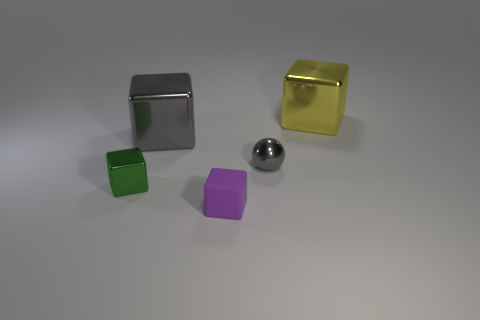There is a small green object; what number of objects are in front of it?
Provide a succinct answer. 1. What color is the other small thing that is the same shape as the green thing?
Offer a terse response. Purple. Does the large cube that is to the left of the large yellow metallic thing have the same material as the purple block in front of the large gray metallic cube?
Ensure brevity in your answer.  No. There is a shiny ball; is its color the same as the big cube that is in front of the yellow object?
Offer a very short reply. Yes. What is the shape of the metallic thing that is on the left side of the yellow metallic object and right of the small rubber cube?
Provide a short and direct response. Sphere. How many gray cubes are there?
Keep it short and to the point. 1. The big shiny thing that is the same color as the ball is what shape?
Give a very brief answer. Cube. There is a gray thing that is the same shape as the green thing; what is its size?
Make the answer very short. Large. Does the gray thing behind the tiny gray shiny ball have the same shape as the yellow object?
Make the answer very short. Yes. There is a thing right of the small metallic sphere; what is its color?
Keep it short and to the point. Yellow. 